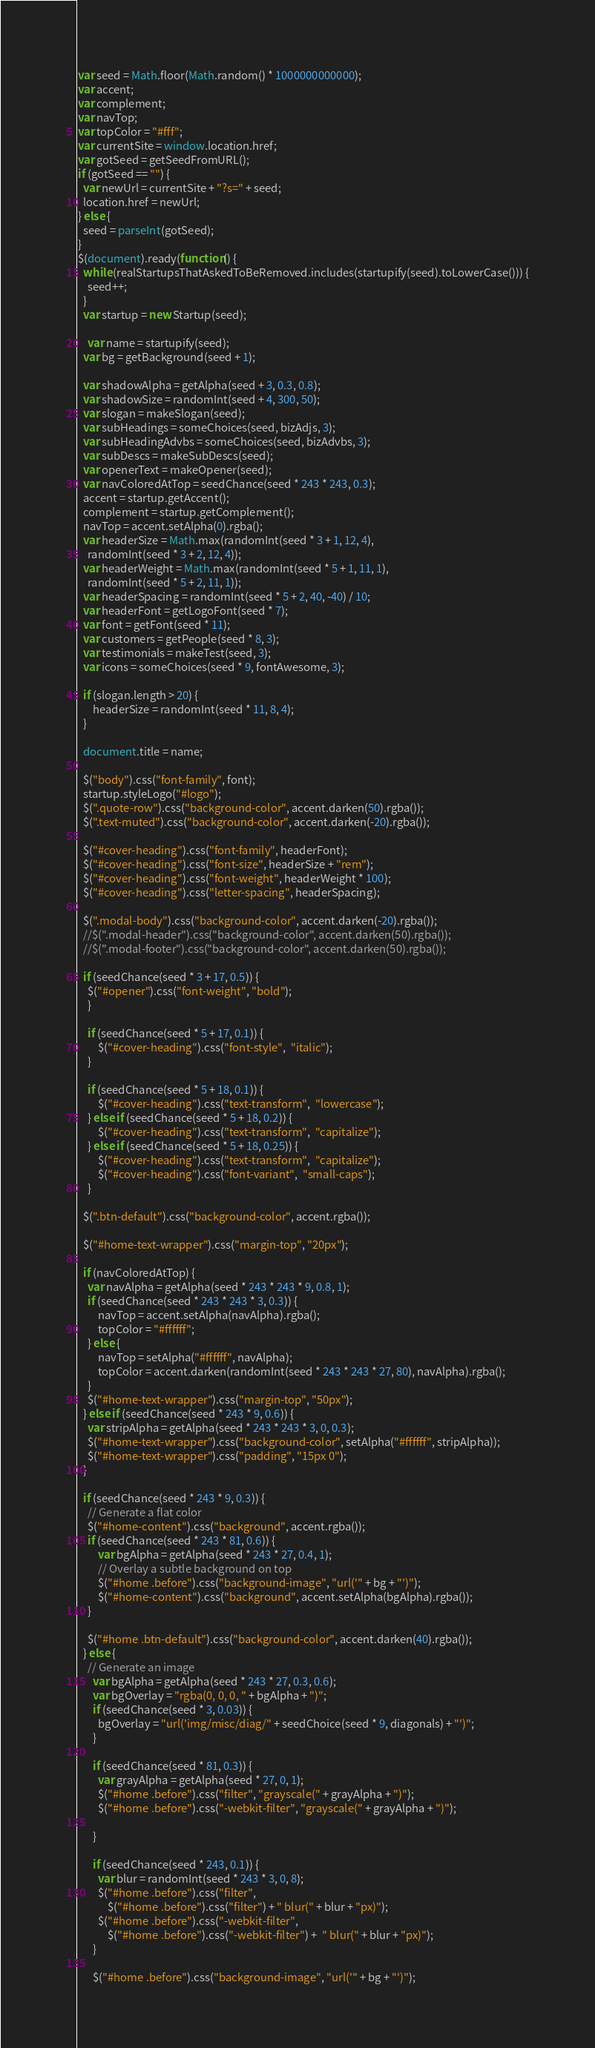<code> <loc_0><loc_0><loc_500><loc_500><_JavaScript_>var seed = Math.floor(Math.random() * 1000000000000);
var accent;
var complement;
var navTop;
var topColor = "#fff";
var currentSite = window.location.href;
var gotSeed = getSeedFromURL();
if (gotSeed == "") {
  var newUrl = currentSite + "?s=" + seed;
  location.href = newUrl;
} else {
  seed = parseInt(gotSeed);
}
$(document).ready(function() {
  while (realStartupsThatAskedToBeRemoved.includes(startupify(seed).toLowerCase())) {
    seed++;
  }
  var startup = new Startup(seed);

	var name = startupify(seed);
  var bg = getBackground(seed + 1);

  var shadowAlpha = getAlpha(seed + 3, 0.3, 0.8);
  var shadowSize = randomInt(seed + 4, 300, 50);
  var slogan = makeSlogan(seed);
  var subHeadings = someChoices(seed, bizAdjs, 3);
  var subHeadingAdvbs = someChoices(seed, bizAdvbs, 3);
  var subDescs = makeSubDescs(seed);
  var openerText = makeOpener(seed);
  var navColoredAtTop = seedChance(seed * 243 * 243, 0.3);
  accent = startup.getAccent();
  complement = startup.getComplement();
  navTop = accent.setAlpha(0).rgba();
  var headerSize = Math.max(randomInt(seed * 3 + 1, 12, 4),
  	randomInt(seed * 3 + 2, 12, 4));
  var headerWeight = Math.max(randomInt(seed * 5 + 1, 11, 1),
  	randomInt(seed * 5 + 2, 11, 1));
  var headerSpacing = randomInt(seed * 5 + 2, 40, -40) / 10;
  var headerFont = getLogoFont(seed * 7);
  var font = getFont(seed * 11);
  var customers = getPeople(seed * 8, 3);
  var testimonials = makeTest(seed, 3);
  var icons = someChoices(seed * 9, fontAwesome, 3);

  if (slogan.length > 20) {
      headerSize = randomInt(seed * 11, 8, 4);
  }

  document.title = name;

  $("body").css("font-family", font);
  startup.styleLogo("#logo");
  $(".quote-row").css("background-color", accent.darken(50).rgba());
  $(".text-muted").css("background-color", accent.darken(-20).rgba());

  $("#cover-heading").css("font-family", headerFont);
  $("#cover-heading").css("font-size", headerSize + "rem");
  $("#cover-heading").css("font-weight", headerWeight * 100);
  $("#cover-heading").css("letter-spacing", headerSpacing);

  $(".modal-body").css("background-color", accent.darken(-20).rgba());
  //$(".modal-header").css("background-color", accent.darken(50).rgba());
  //$(".modal-footer").css("background-color", accent.darken(50).rgba());

  if (seedChance(seed * 3 + 17, 0.5)) {
  	$("#opener").css("font-weight", "bold");
	}

	if (seedChance(seed * 5 + 17, 0.1)) {
		$("#cover-heading").css("font-style",  "italic");
	}

	if (seedChance(seed * 5 + 18, 0.1)) {
		$("#cover-heading").css("text-transform",  "lowercase");
	} else if (seedChance(seed * 5 + 18, 0.2)) {
		$("#cover-heading").css("text-transform",  "capitalize");
	} else if (seedChance(seed * 5 + 18, 0.25)) {
		$("#cover-heading").css("text-transform",  "capitalize");
		$("#cover-heading").css("font-variant",  "small-caps");
	}

  $(".btn-default").css("background-color", accent.rgba());

  $("#home-text-wrapper").css("margin-top", "20px");

  if (navColoredAtTop) {
  	var navAlpha = getAlpha(seed * 243 * 243 * 9, 0.8, 1);
  	if (seedChance(seed * 243 * 243 * 3, 0.3)) {
  		navTop = accent.setAlpha(navAlpha).rgba();
  		topColor = "#ffffff";
  	} else {
  		navTop = setAlpha("#ffffff", navAlpha);
  		topColor = accent.darken(randomInt(seed * 243 * 243 * 27, 80), navAlpha).rgba();
  	}
  	$("#home-text-wrapper").css("margin-top", "50px");
  } else if (seedChance(seed * 243 * 9, 0.6)) {
  	var stripAlpha = getAlpha(seed * 243 * 243 * 3, 0, 0.3);
  	$("#home-text-wrapper").css("background-color", setAlpha("#ffffff", stripAlpha));
  	$("#home-text-wrapper").css("padding", "15px 0");
  }

  if (seedChance(seed * 243 * 9, 0.3)) {
  	// Generate a flat color
  	$("#home-content").css("background", accent.rgba());
  	if (seedChance(seed * 243 * 81, 0.6)) {
  		var bgAlpha = getAlpha(seed * 243 * 27, 0.4, 1);
  		// Overlay a subtle background on top
  		$("#home .before").css("background-image", "url('" + bg + "')");
  		$("#home-content").css("background", accent.setAlpha(bgAlpha).rgba());
  	}

  	$("#home .btn-default").css("background-color", accent.darken(40).rgba());
  } else {
  	// Generate an image
	  var bgAlpha = getAlpha(seed * 243 * 27, 0.3, 0.6);
	  var bgOverlay = "rgba(0, 0, 0, " + bgAlpha + ")";
	  if (seedChance(seed * 3, 0.03)) {
	    bgOverlay = "url('img/misc/diag/" + seedChoice(seed * 9, diagonals) + "')";
	  }

	  if (seedChance(seed * 81, 0.3)) {
	  	var grayAlpha = getAlpha(seed * 27, 0, 1);
	  	$("#home .before").css("filter", "grayscale(" + grayAlpha + ")");
	  	$("#home .before").css("-webkit-filter", "grayscale(" + grayAlpha + ")");

	  }

	  if (seedChance(seed * 243, 0.1)) {
	  	var blur = randomInt(seed * 243 * 3, 0, 8);
	  	$("#home .before").css("filter",
	  		$("#home .before").css("filter") + " blur(" + blur + "px)");
	  	$("#home .before").css("-webkit-filter",
	  		$("#home .before").css("-webkit-filter") +  " blur(" + blur + "px)");
	  }

	  $("#home .before").css("background-image", "url('" + bg + "')");</code> 